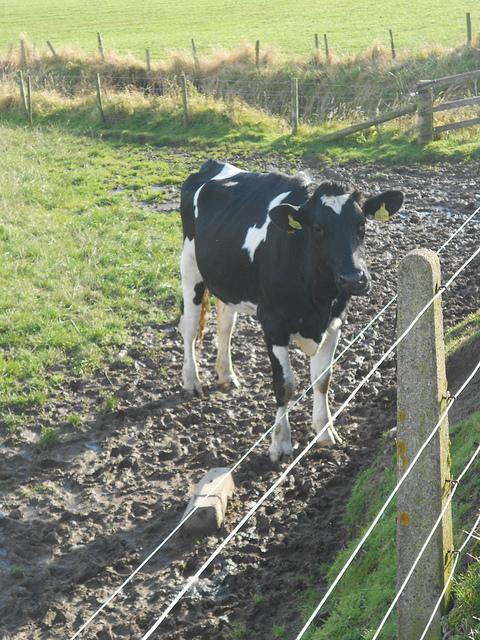How big is the cow?
Keep it brief. Small. Can the cow get to the camera?
Answer briefly. No. Is the fence made of pipes?
Answer briefly. No. Is there a barn in the picture?
Concise answer only. No. Does the cow look clean or dirty?
Be succinct. Clean. 